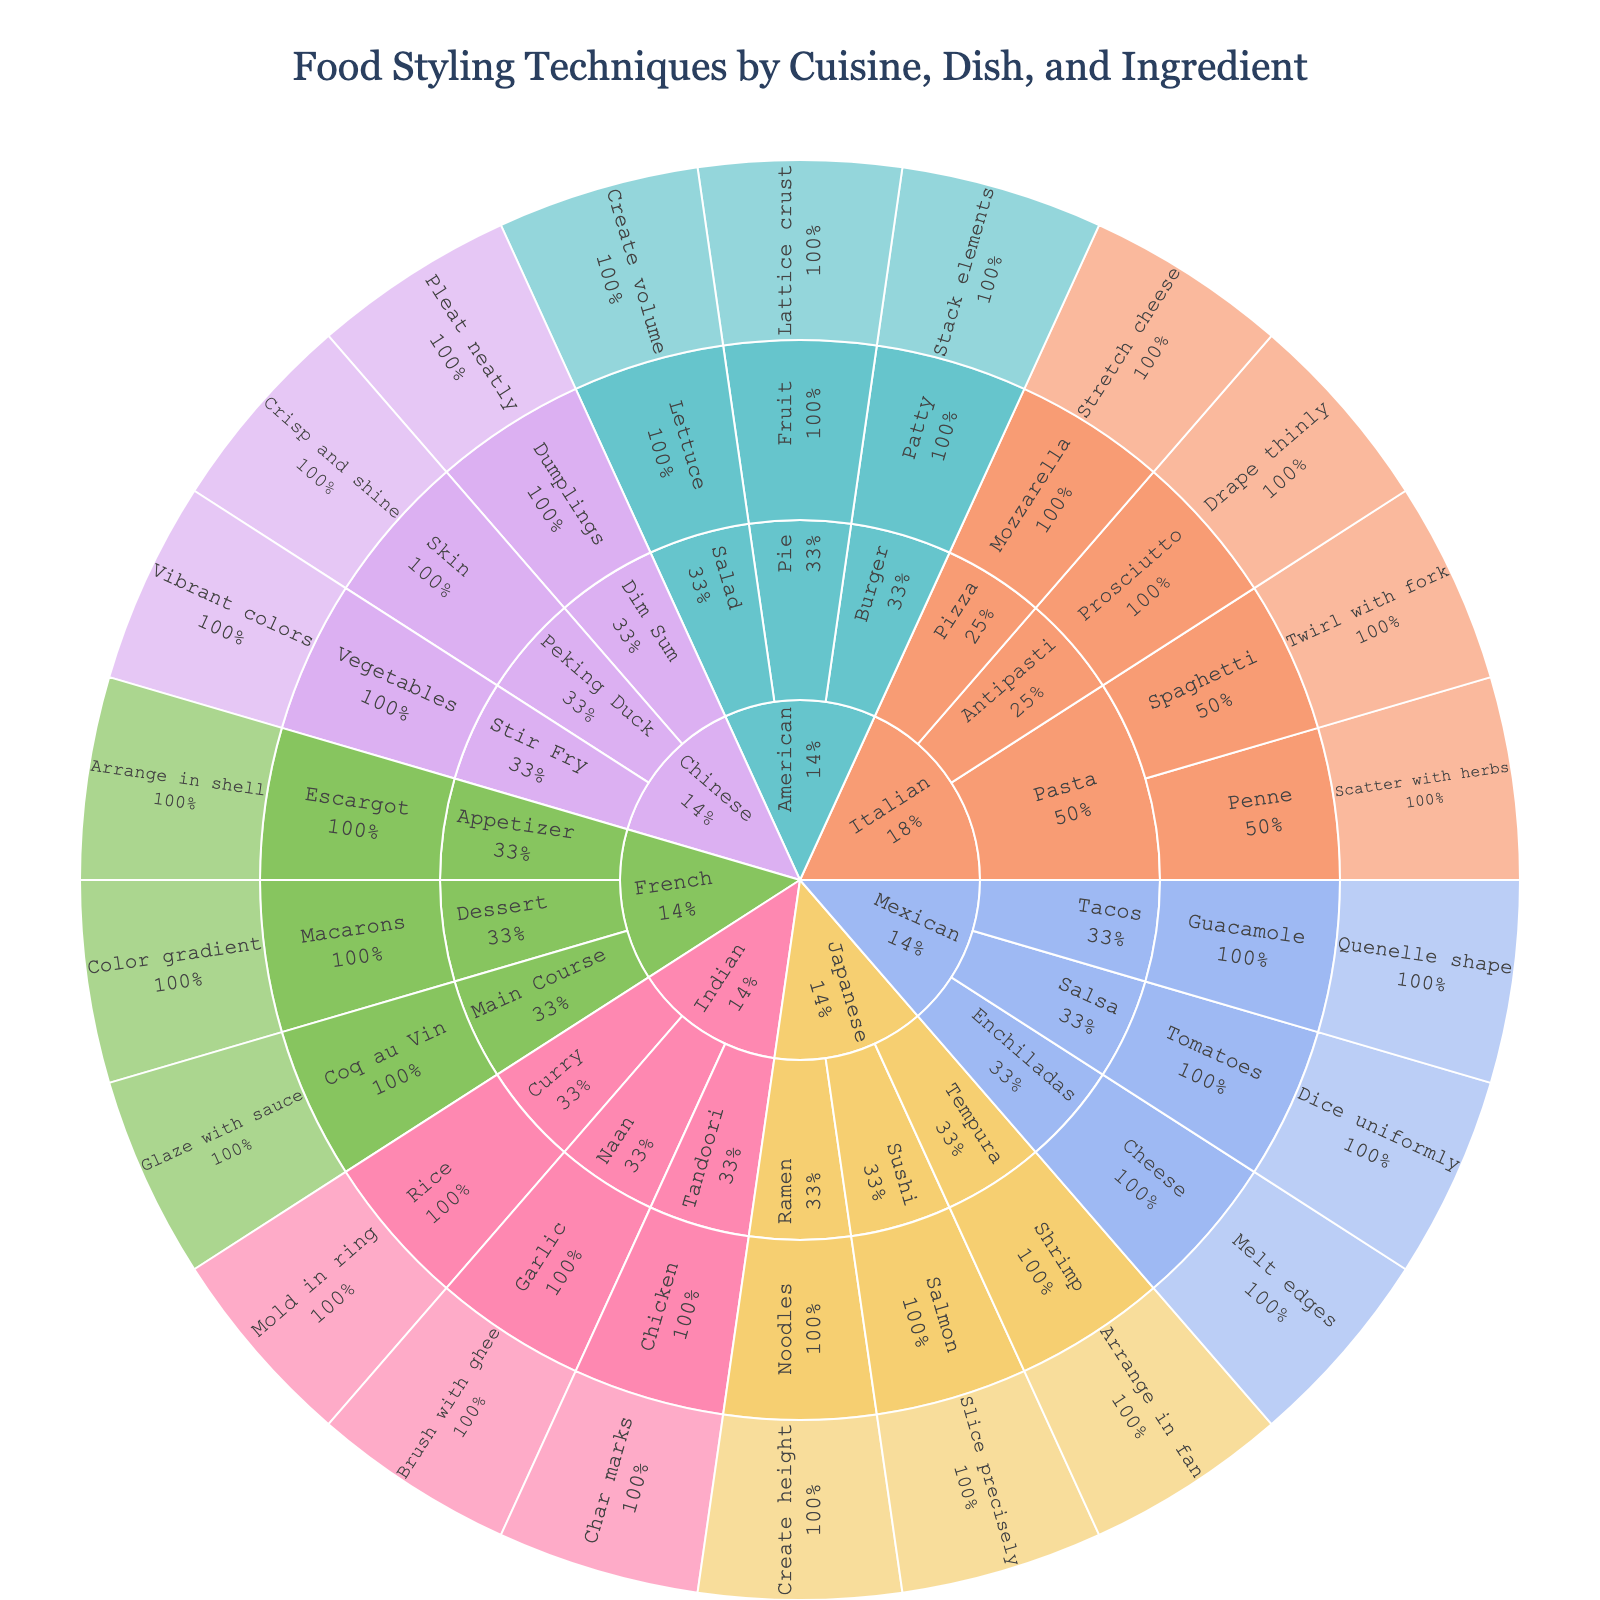What is the title of the sunburst plot? The title is displayed at the top of the plot. It provides an overall description of what the data is about.
Answer: Food Styling Techniques by Cuisine, Dish, and Ingredient Which cuisines are represented in the plot? The first level of the sunburst plot shows the main categories, which represent the different cuisines.
Answer: Italian, French, Japanese, Mexican, Indian, American, Chinese In the Italian cuisine category, what techniques are used for pasta dishes? Find the segment for Italian cuisine, then locate the sub-segments for pasta dishes, and check the descriptions of the techniques used for each ingredient within this category.
Answer: Twirl with fork (Spaghetti), Scatter with herbs (Penne) How many dish categories are there in the French cuisine segment? To answer this, find the French cuisine segment and count the number of dish category sub-segments within that section.
Answer: Three Which cuisine uses the technique "Quenelle shape" and for which ingredient? Search through the plot for the technique "Quenelle shape" and follow its path up to see the related ingredient and cuisine.
Answer: Mexican, Guacamole What is the most visual cuisine segment in the plot? The segment with the largest area or most subdivisions represents the most visual cuisine.
Answer: Italian Which technique is associated with American pies? Look at the American cuisine segment, find the pie category, and identify the technique listed for pies.
Answer: Lattice crust Which cuisine has the technique of "Create height" and for which dish category and ingredient? Locate the technique "Create height" in the plot, then trace back to the relevant cuisine, dish category, and ingredient.
Answer: Japanese, Ramen, Noodles Compare Italian and American cuisines in terms of the number of dish categories. Which one has more, and by how many? Count the dish categories within the Italian and American cuisine segments, then find the difference between them.
Answer: Italian has 3, American has 3; difference is 0 Is there any cuisine that does not use any color-related techniques? If so, which one(s)? Check each cuisine segment to see if any have techniques that do not mention color.
Answer: Yes, cuisines like Italian, Japanese, Mexican, Indian, American, and Chinese do not mention color techniques 